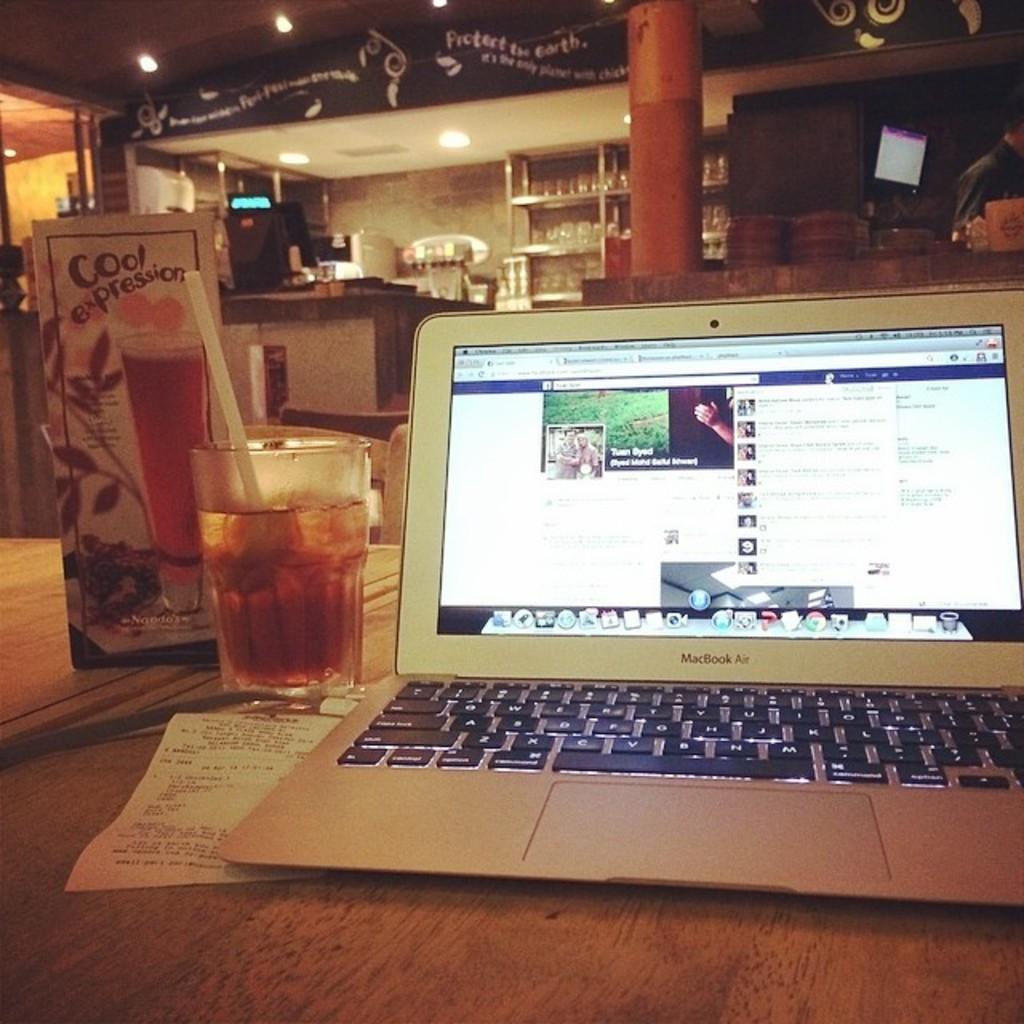In one or two sentences, can you explain what this image depicts? In this image i can see a laptop, a glass with a straw in it and a piece of paper on a table. In the background i can see a shelf, some lights to the ceiling and a roof. 